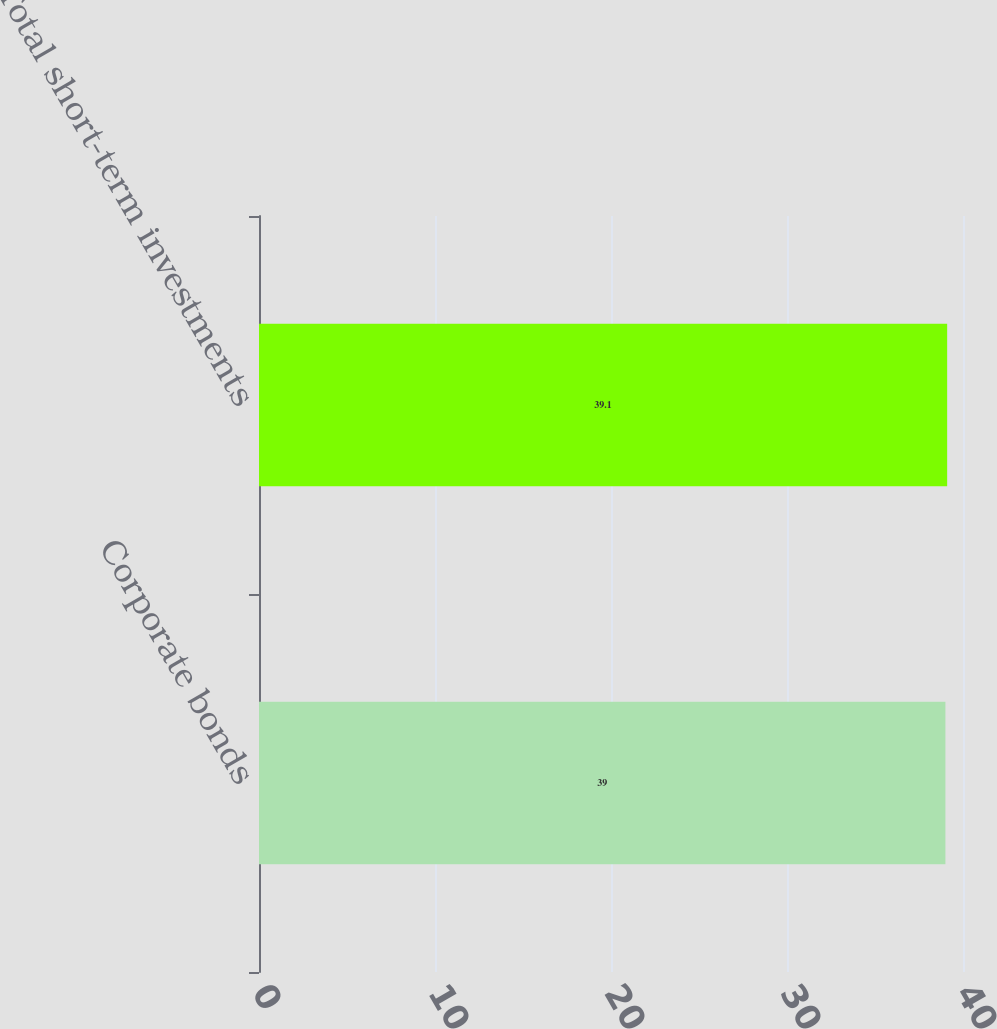Convert chart. <chart><loc_0><loc_0><loc_500><loc_500><bar_chart><fcel>Corporate bonds<fcel>Total short-term investments<nl><fcel>39<fcel>39.1<nl></chart> 